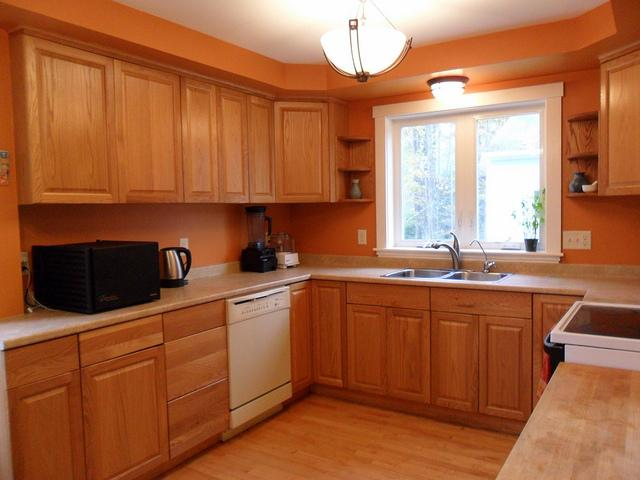What heats the stove for cooking? electricity 